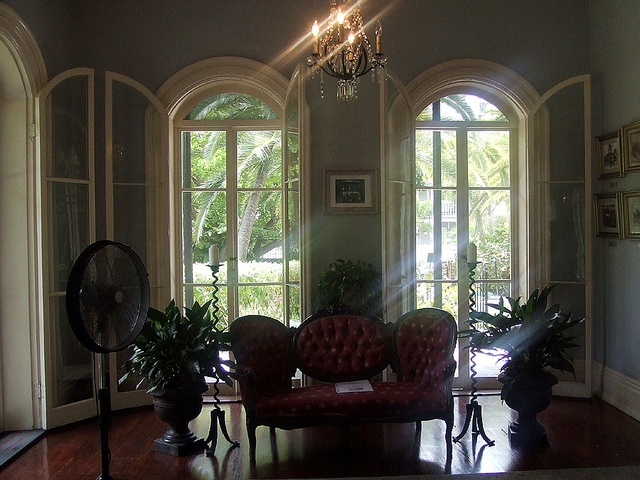Describe the objects in this image and their specific colors. I can see potted plant in black, gray, white, and darkgray tones, potted plant in black, gray, darkgray, and white tones, chair in black, gray, ivory, and darkgray tones, chair in black tones, and potted plant in black, gray, darkblue, and purple tones in this image. 